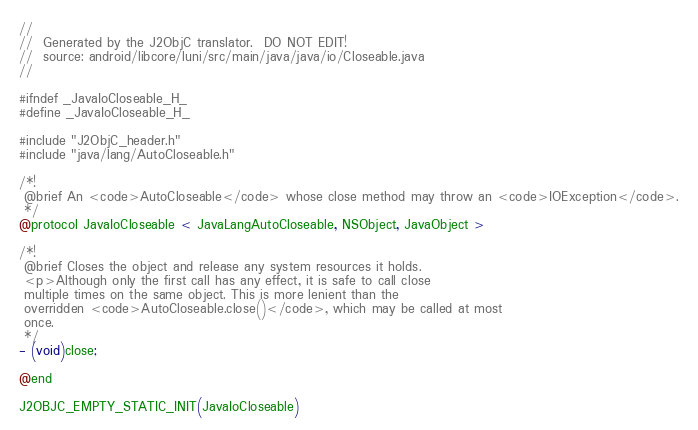<code> <loc_0><loc_0><loc_500><loc_500><_C_>//
//  Generated by the J2ObjC translator.  DO NOT EDIT!
//  source: android/libcore/luni/src/main/java/java/io/Closeable.java
//

#ifndef _JavaIoCloseable_H_
#define _JavaIoCloseable_H_

#include "J2ObjC_header.h"
#include "java/lang/AutoCloseable.h"

/*!
 @brief An <code>AutoCloseable</code> whose close method may throw an <code>IOException</code>.
 */
@protocol JavaIoCloseable < JavaLangAutoCloseable, NSObject, JavaObject >

/*!
 @brief Closes the object and release any system resources it holds.
 <p>Although only the first call has any effect, it is safe to call close
 multiple times on the same object. This is more lenient than the
 overridden <code>AutoCloseable.close()</code>, which may be called at most
 once.
 */
- (void)close;

@end

J2OBJC_EMPTY_STATIC_INIT(JavaIoCloseable)
</code> 